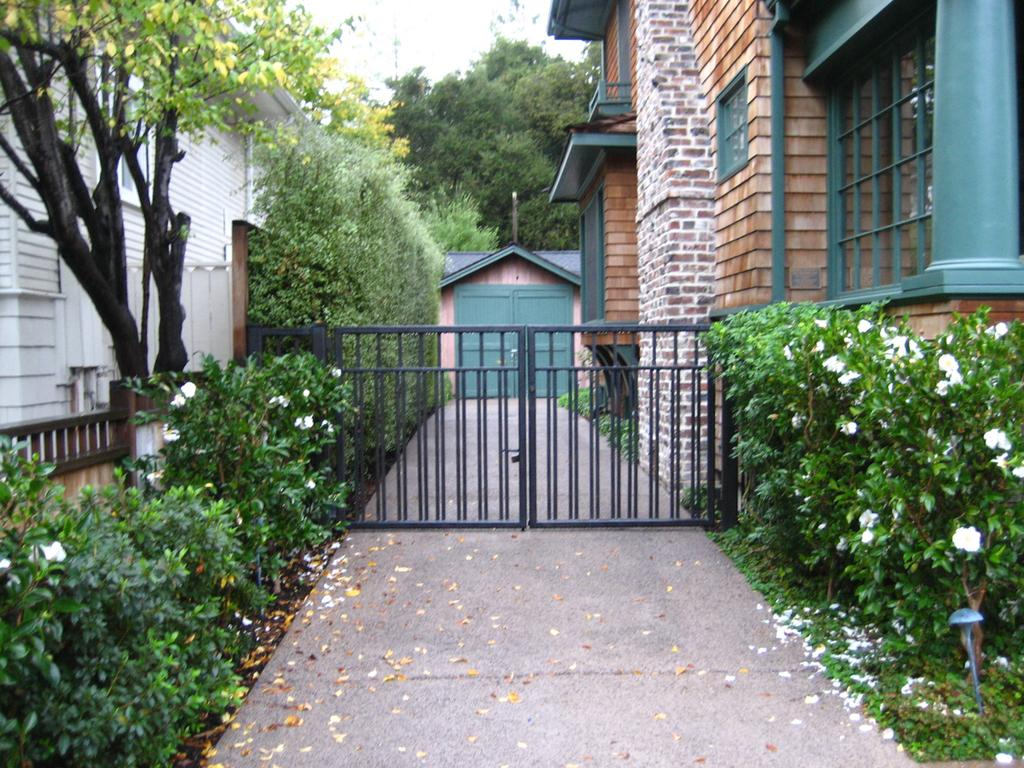What types of vegetation can be seen in the image? There are plants and flowers in the image. What structures are visible in the image? There are buildings and a gate in the image. What type of natural environment is present in the image? There are trees in the image. What is visible in the background of the image? The sky is visible in the image. How many bikes are parked near the gate in the image? There are no bikes present in the image. What type of suit is hanging on the tree in the image? There is no suit hanging on the tree in the image; only plants, flowers, buildings, trees, and a gate are present. 